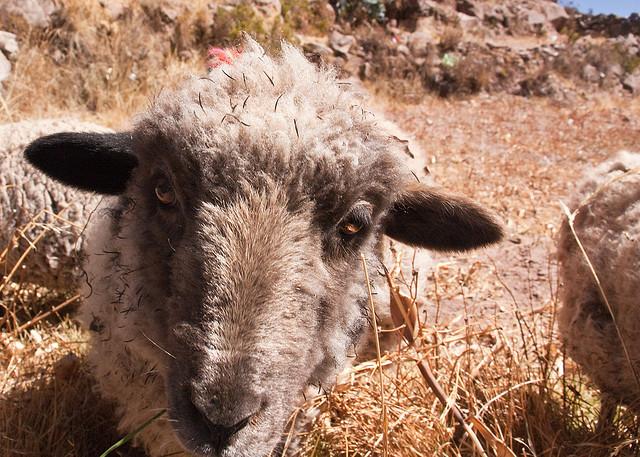Could you get bacon from this animal?
Write a very short answer. No. What type of animal is in this picture?
Write a very short answer. Sheep. What is the animal laying on?
Write a very short answer. Grass. 